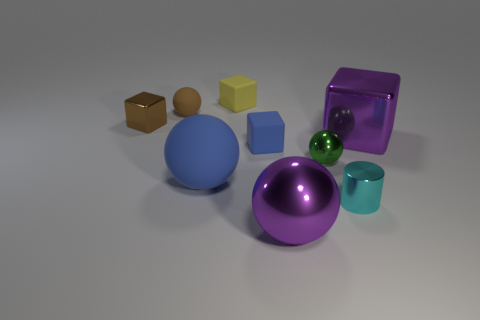Can you describe the lighting and shading in the scene? Certainly! The lighting in the scene appears to be soft and diffused, with the shadows being quite gentle and not overly pronounced, suggesting an ambient light source. This creates a calm and even light, reducing harsh contrasts. The objects have subtle highlights and soft-edged shadows that contribute to the dimensionality of the objects. The light seems to be coming from the upper right, as indicated by the direction of the shadows. The overall effect creates a serene, almost studio-like lighting environment. 